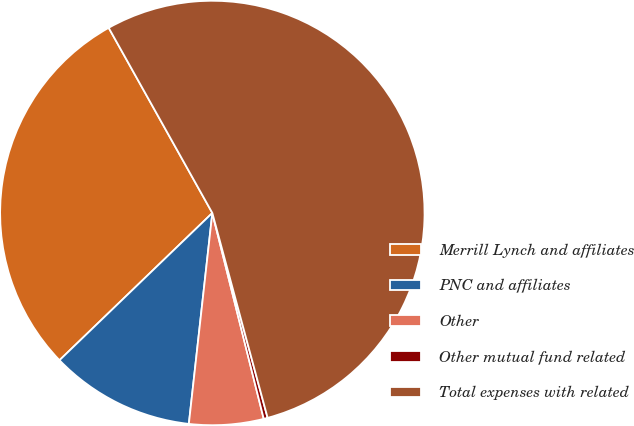<chart> <loc_0><loc_0><loc_500><loc_500><pie_chart><fcel>Merrill Lynch and affiliates<fcel>PNC and affiliates<fcel>Other<fcel>Other mutual fund related<fcel>Total expenses with related<nl><fcel>29.08%<fcel>11.03%<fcel>5.66%<fcel>0.3%<fcel>53.92%<nl></chart> 